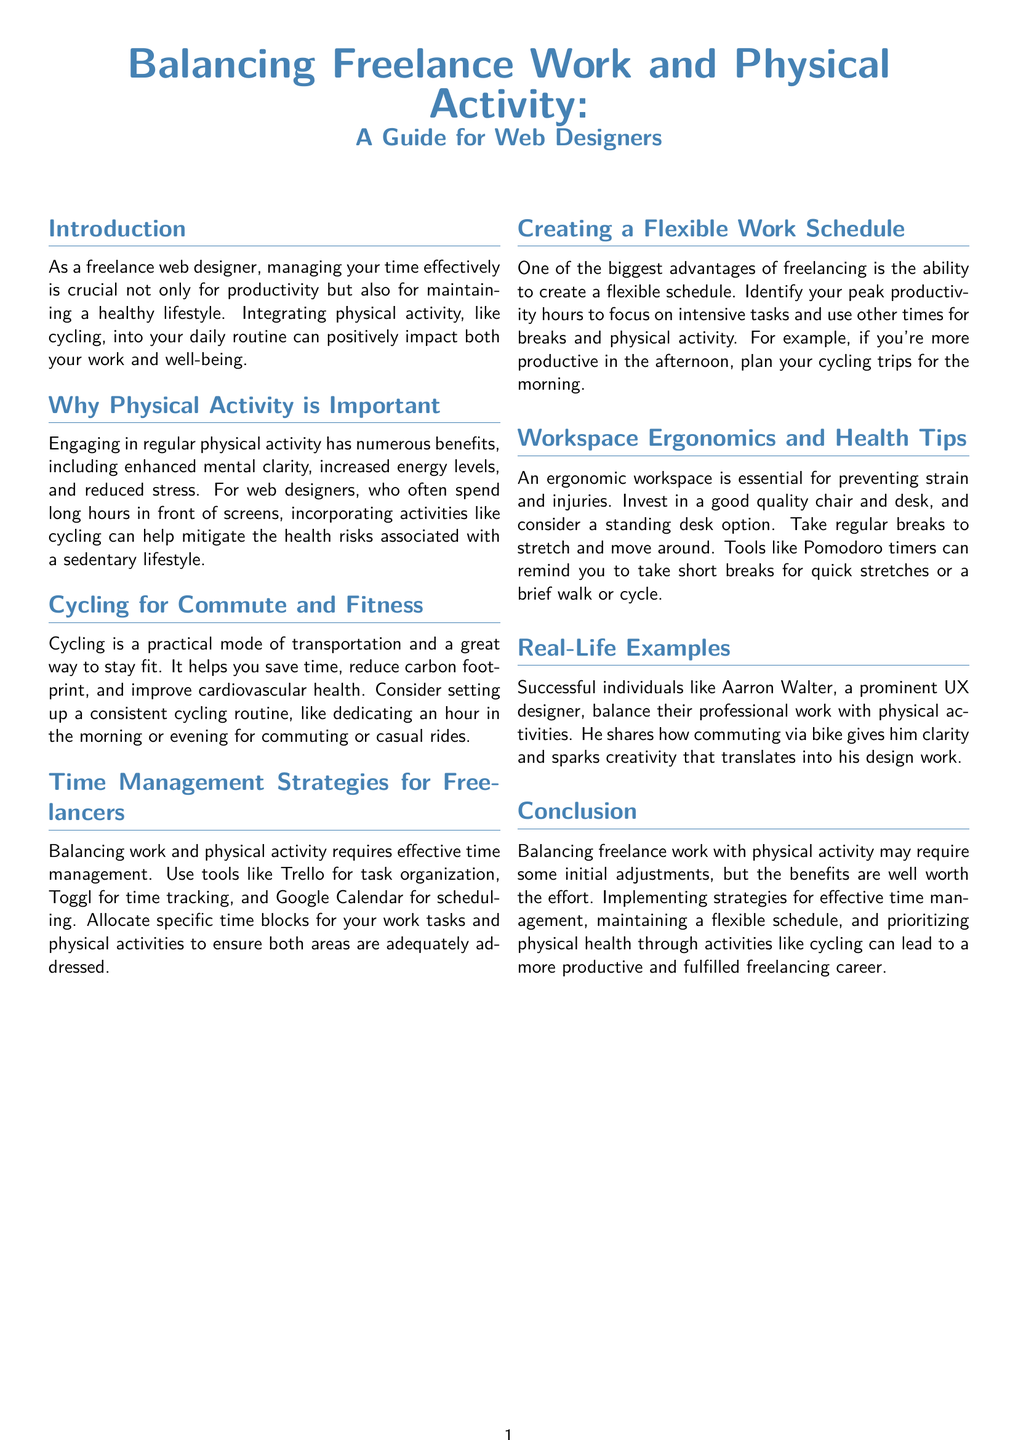What is the main focus of the whitepaper? The main focus of the whitepaper is balancing freelance work and physical activity for web designers.
Answer: Balancing freelance work and physical activity What color is used for section titles? The color used for section titles is defined as cycleblue in the document.
Answer: cycleblue Which physical activity is specifically recommended for web designers? The whitepaper recommends cycling as a physical activity for web designers.
Answer: Cycling What are two tools mentioned for task organization and time tracking? The whitepaper mentions Trello for task organization and Toggl for time tracking.
Answer: Trello, Toggl Name a successful individual mentioned in the document. A successful individual mentioned in the document is Aarron Walter.
Answer: Aarron Walter What is a suggested time allocation for cycling rides? The document suggests dedicating an hour in the morning or evening for commuting or casual rides.
Answer: An hour in the morning or evening What does the whitepaper suggest about workspace ergonomics? The whitepaper suggests investing in a good quality chair and desk to maintain workspace ergonomics.
Answer: Invest in a good quality chair and desk What is one benefit of engaging in regular physical activity according to the document? One benefit mentioned is enhanced mental clarity.
Answer: Enhanced mental clarity What should freelancers identify to create a flexible schedule? Freelancers should identify their peak productivity hours to create a flexible schedule.
Answer: Peak productivity hours 